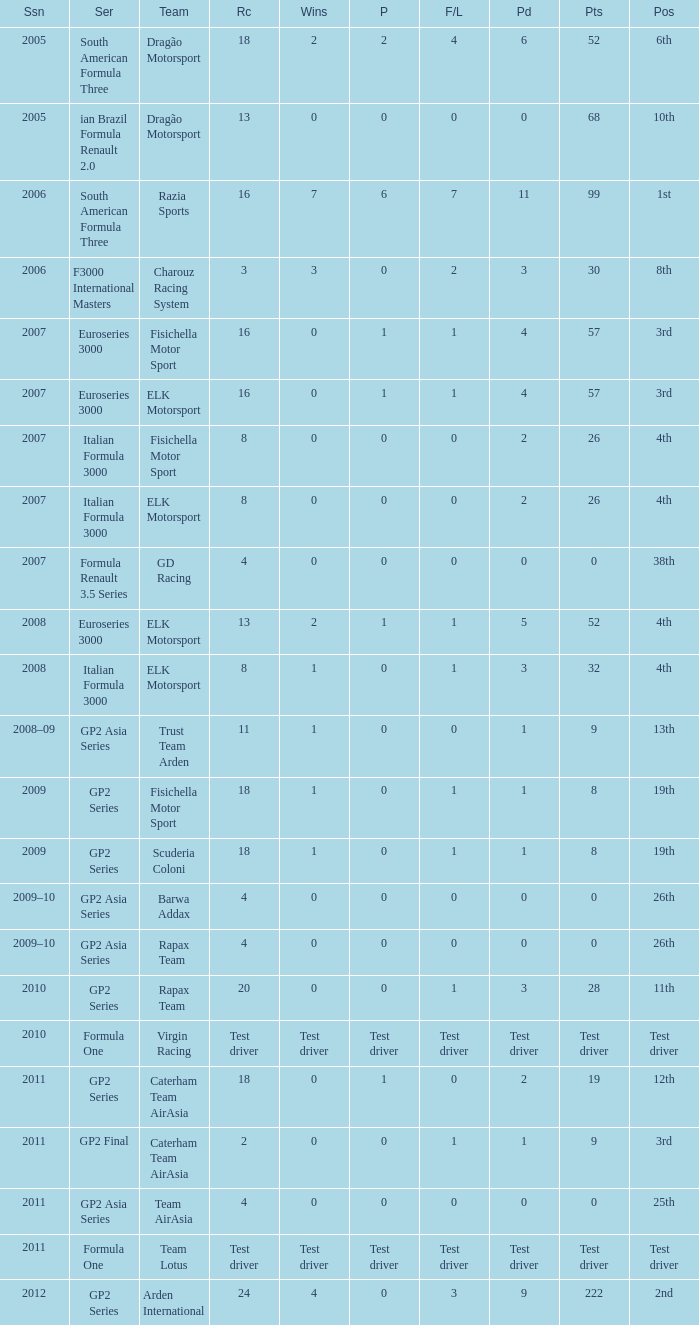What was the F/Laps when the Wins were 0 and the Position was 4th? 0, 0. 